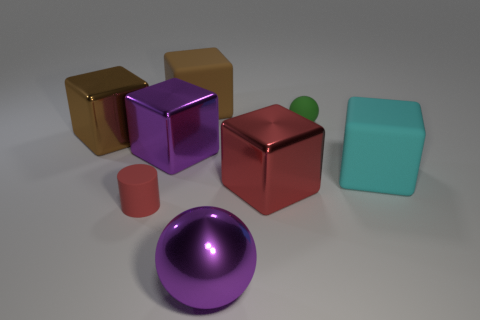Subtract all brown blocks. How many were subtracted if there are1brown blocks left? 1 Subtract all red cubes. How many cubes are left? 4 Subtract all large brown rubber cubes. How many cubes are left? 4 Add 2 big cyan rubber objects. How many objects exist? 10 Subtract all green blocks. Subtract all red balls. How many blocks are left? 5 Subtract all blocks. How many objects are left? 3 Subtract all big red blocks. Subtract all small balls. How many objects are left? 6 Add 4 big red metal cubes. How many big red metal cubes are left? 5 Add 3 tiny blue rubber spheres. How many tiny blue rubber spheres exist? 3 Subtract 0 gray cubes. How many objects are left? 8 